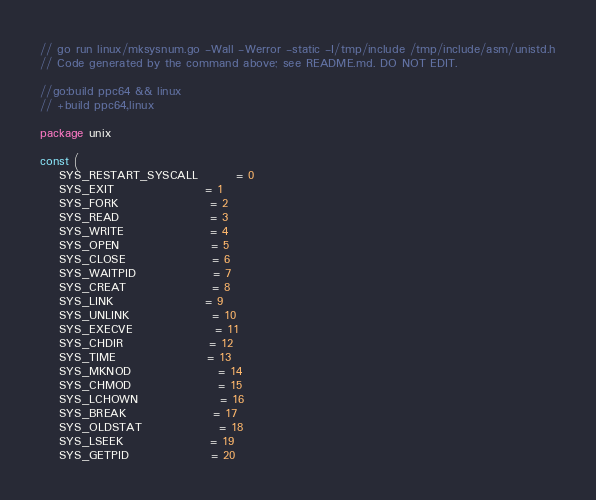<code> <loc_0><loc_0><loc_500><loc_500><_Go_>// go run linux/mksysnum.go -Wall -Werror -static -I/tmp/include /tmp/include/asm/unistd.h
// Code generated by the command above; see README.md. DO NOT EDIT.

//go:build ppc64 && linux
// +build ppc64,linux

package unix

const (
	SYS_RESTART_SYSCALL        = 0
	SYS_EXIT                   = 1
	SYS_FORK                   = 2
	SYS_READ                   = 3
	SYS_WRITE                  = 4
	SYS_OPEN                   = 5
	SYS_CLOSE                  = 6
	SYS_WAITPID                = 7
	SYS_CREAT                  = 8
	SYS_LINK                   = 9
	SYS_UNLINK                 = 10
	SYS_EXECVE                 = 11
	SYS_CHDIR                  = 12
	SYS_TIME                   = 13
	SYS_MKNOD                  = 14
	SYS_CHMOD                  = 15
	SYS_LCHOWN                 = 16
	SYS_BREAK                  = 17
	SYS_OLDSTAT                = 18
	SYS_LSEEK                  = 19
	SYS_GETPID                 = 20</code> 